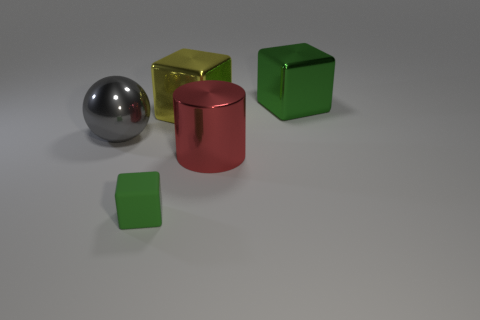The other object that is the same color as the tiny thing is what shape?
Offer a very short reply. Cube. There is a large metal thing behind the big block left of the cube that is to the right of the large red shiny cylinder; what is its shape?
Provide a short and direct response. Cube. What number of other things are there of the same shape as the big green metal object?
Provide a short and direct response. 2. What number of metallic things are either yellow cubes or tiny gray things?
Offer a terse response. 1. What material is the block that is to the right of the shiny cylinder behind the tiny matte block made of?
Provide a short and direct response. Metal. Are there more green shiny things that are behind the big cylinder than tiny cyan matte cubes?
Keep it short and to the point. Yes. Is there a yellow block that has the same material as the sphere?
Keep it short and to the point. Yes. There is a green thing behind the large gray thing; is its shape the same as the tiny green matte object?
Ensure brevity in your answer.  Yes. How many objects are in front of the metal cylinder to the right of the yellow thing that is right of the big gray shiny object?
Your answer should be very brief. 1. Are there fewer large metal cubes that are behind the green metallic cube than green cubes that are in front of the yellow metallic thing?
Give a very brief answer. Yes. 